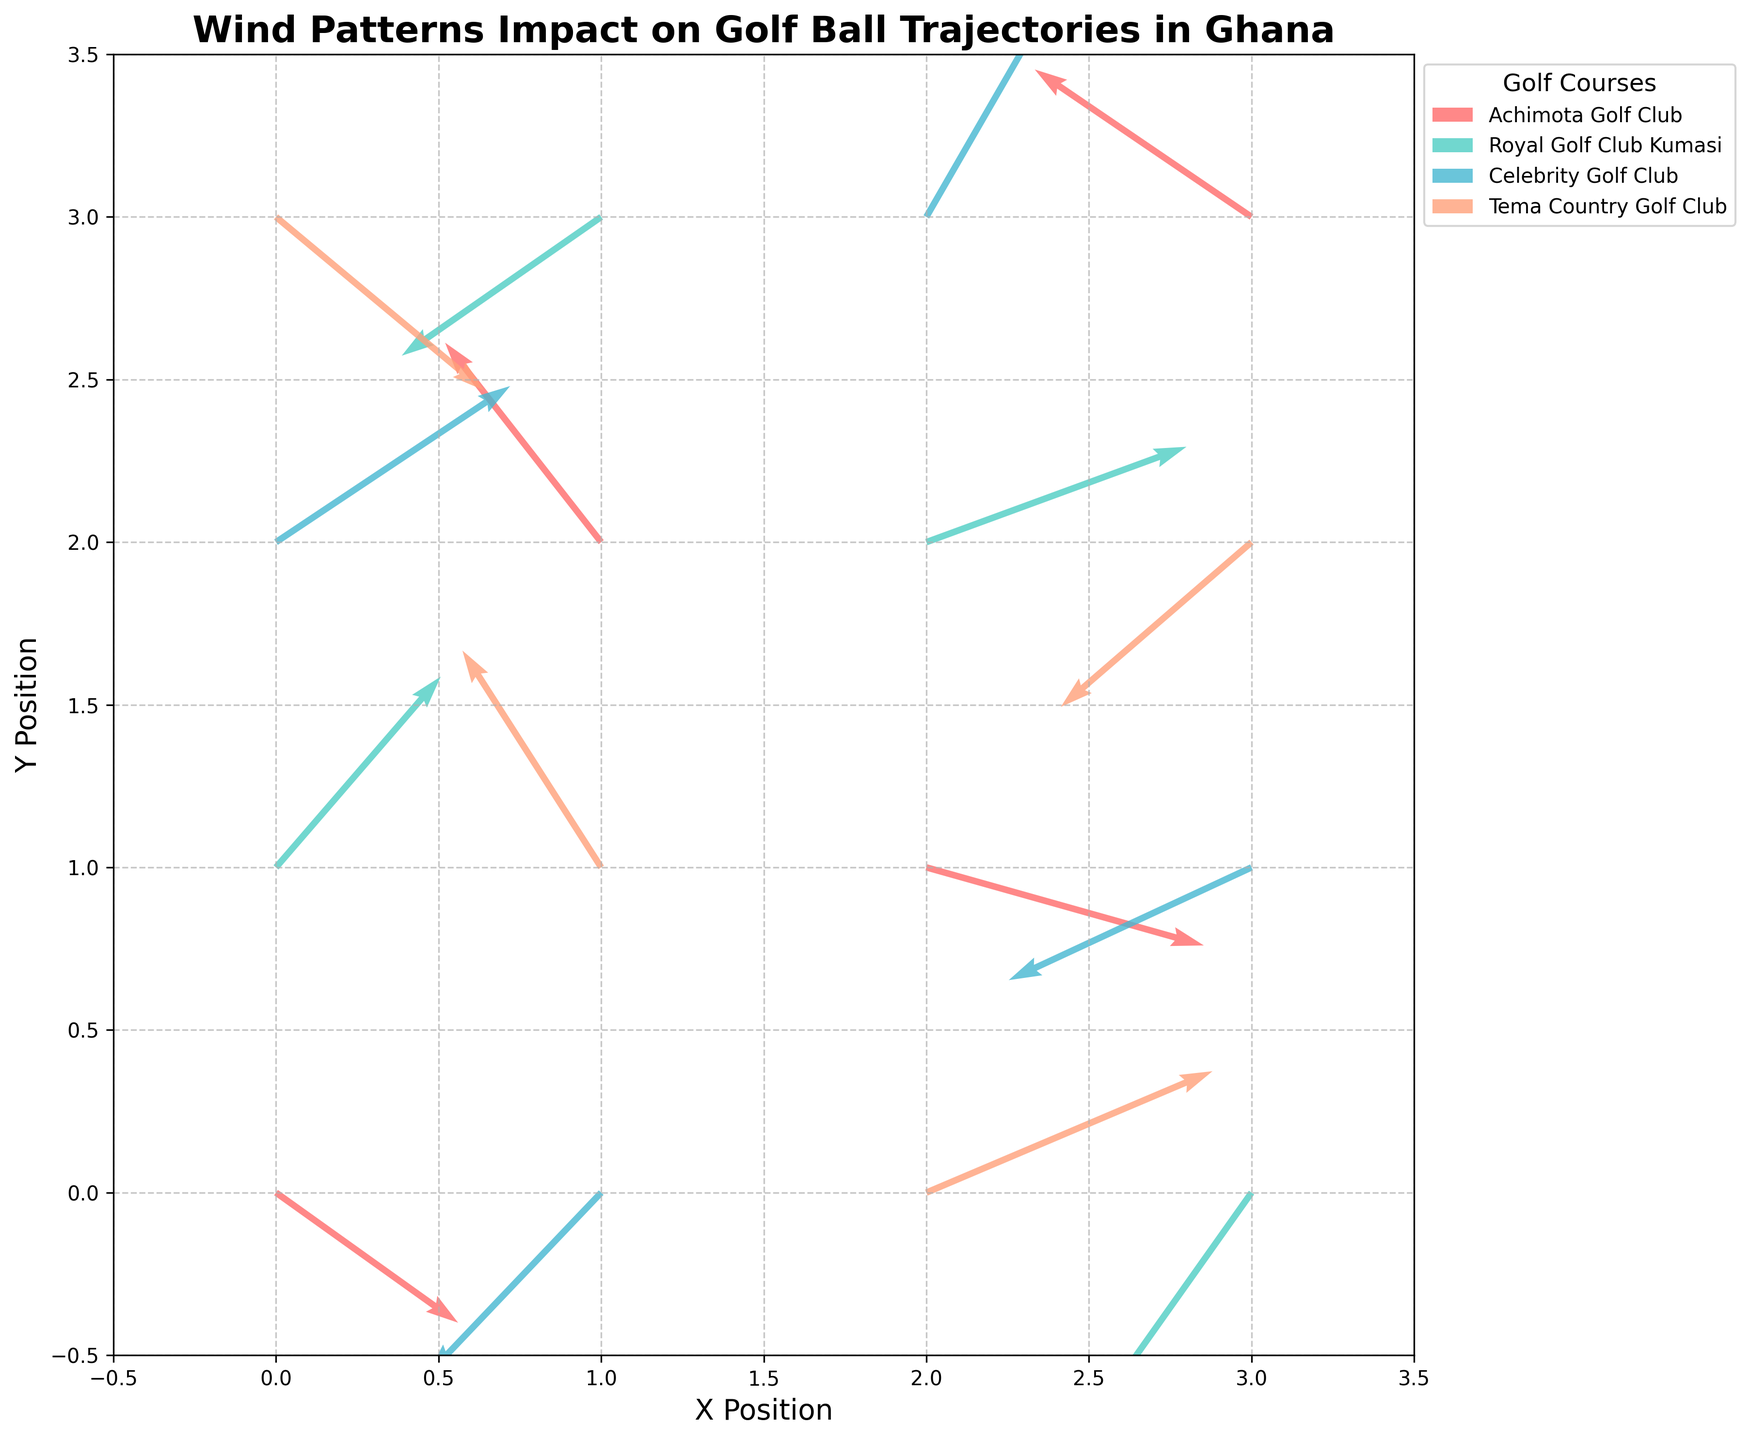What is the title of the plot? The plot's title is readable at the top of the figure, reflecting the essence of the data presented.
Answer: Wind Patterns Impact on Golf Ball Trajectories in Ghana How many golf courses are represented in this plot? By observing the legend on the right side of the plot, you can count the number of unique golf courses listed.
Answer: 4 Which course has a wind vector pointing in the general direction of (-2.5, 1.7)? By comparing the wind vector directions in the plot with the specified vector, you can spot that the indicated vector belongs to Achimota Golf Club.
Answer: Achimota Golf Club Between Celebrity Golf Club and Tema Country Golf Club, which one has a higher impact of wind at the origin (0,0)? By observing the vector magnitudes at the point (0,0) for both courses, you can see which has longer vectors indicating higher wind impact.
Answer: Tema Country Golf Club What is the wind direction at (1,3) for Royal Golf Club Kumasi? Locate the position (1,3) on the plot and check the vector direction for Royal Golf Club Kumasi which points downwards and left.
Answer: (-2.3, -1.6) Compare the wind vectors at (2,3) for Celebrity Golf Club and Royal Golf Club Kumasi. Which has a stronger wind influence? Look at the vectors emanating from (2,3) and compare their lengths. Celebrity Golf Club has a more pronounced vector.
Answer: Celebrity Golf Club At point (3,1), which course's wind pattern pushes the ball towards the upper left? Identify the wind vector directions at (3,1) and find which course has a vector pointing towards the upper left.
Answer: Celebrity Golf Club Which golf course has the wind vector with the greatest upward component? By checking the y-components of the wind vectors, you find that the largest positive y-component belongs to Tema Country Golf Club at (1,1).
Answer: Tema Country Golf Club At location (0,1), which course's wind pattern pushes the golf ball upwards? Examine the vectors at (0,1) to detect which has an upward component. Royal Golf Club Kumasi's vector points upwards.
Answer: Royal Golf Club Kumasi What is the cumulative horizontal wind impact at (1,2) for all courses? Sum the horizontal components (u) of all wind vectors present at (1,2) for the different courses.
Answer: -1.8 